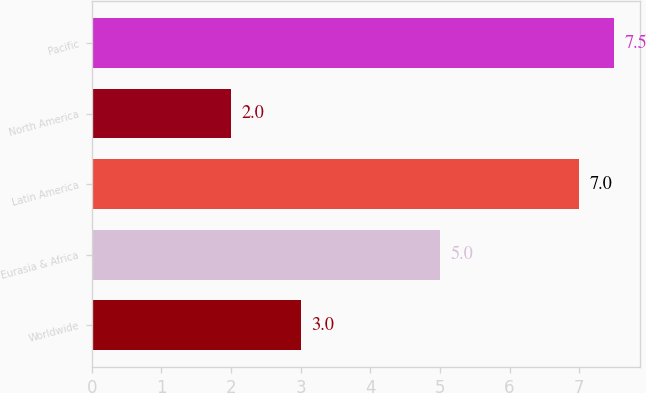Convert chart to OTSL. <chart><loc_0><loc_0><loc_500><loc_500><bar_chart><fcel>Worldwide<fcel>Eurasia & Africa<fcel>Latin America<fcel>North America<fcel>Pacific<nl><fcel>3<fcel>5<fcel>7<fcel>2<fcel>7.5<nl></chart> 